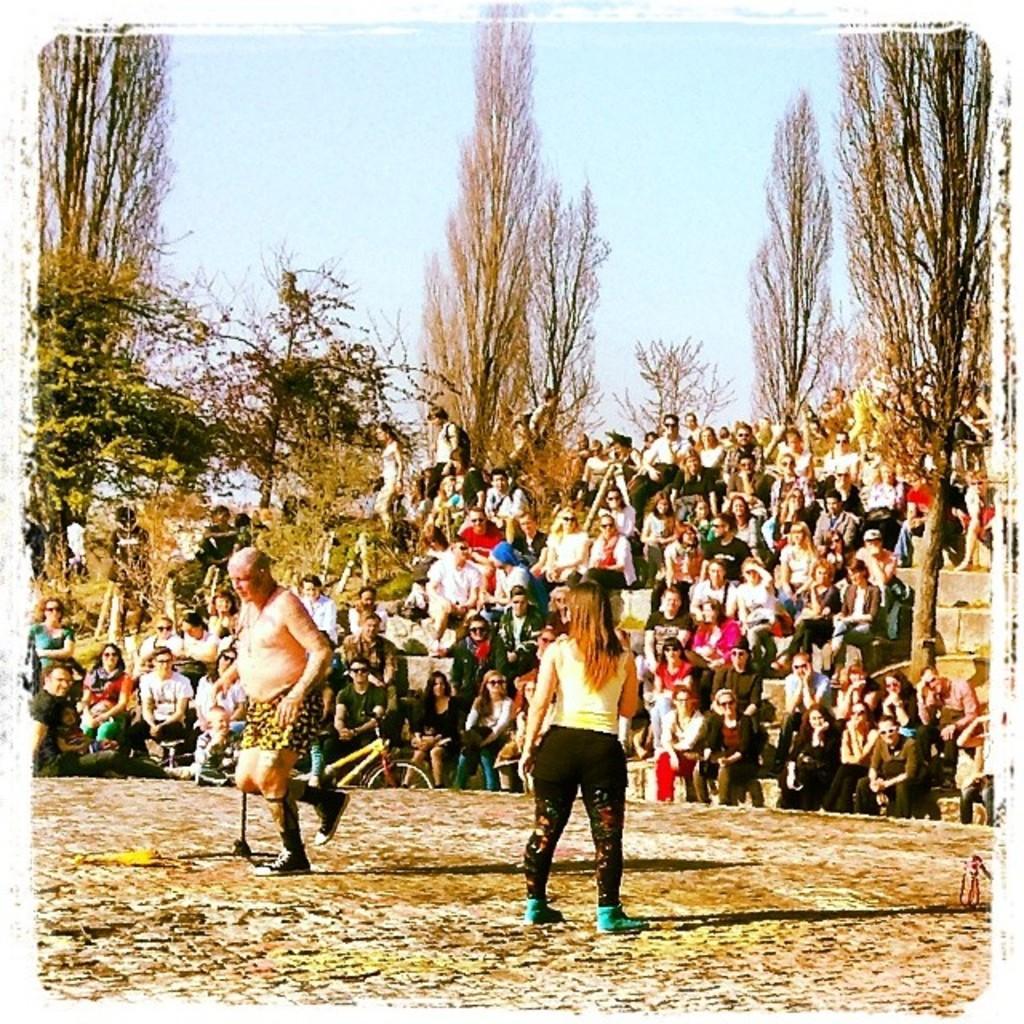Could you give a brief overview of what you see in this image? In this image there is a person hopping on a leg, beside the person there is a woman standing, behind the person there are a few people sitting on stairs and watching them, in the background of the image there are trees. 